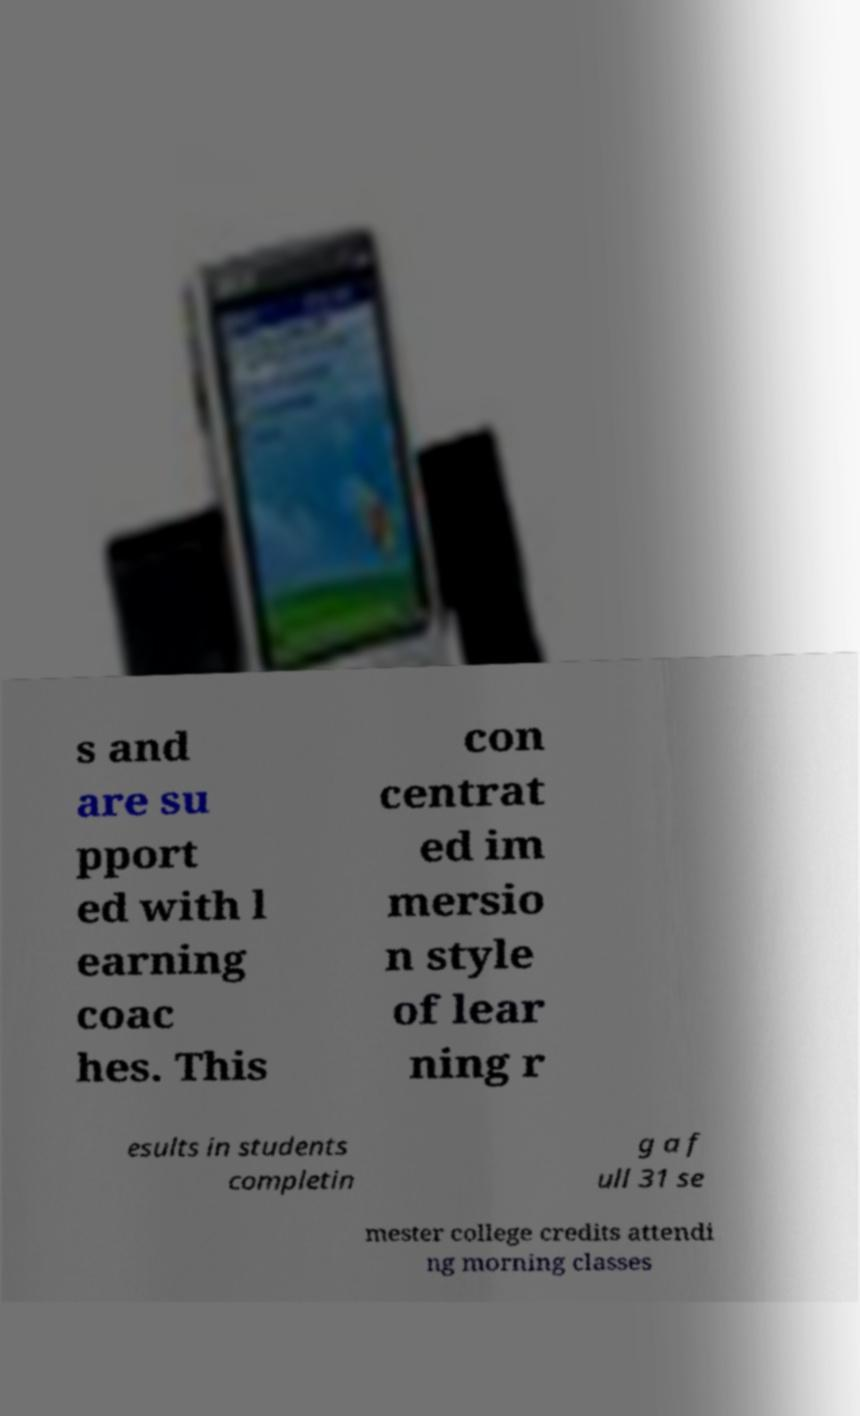Can you accurately transcribe the text from the provided image for me? s and are su pport ed with l earning coac hes. This con centrat ed im mersio n style of lear ning r esults in students completin g a f ull 31 se mester college credits attendi ng morning classes 